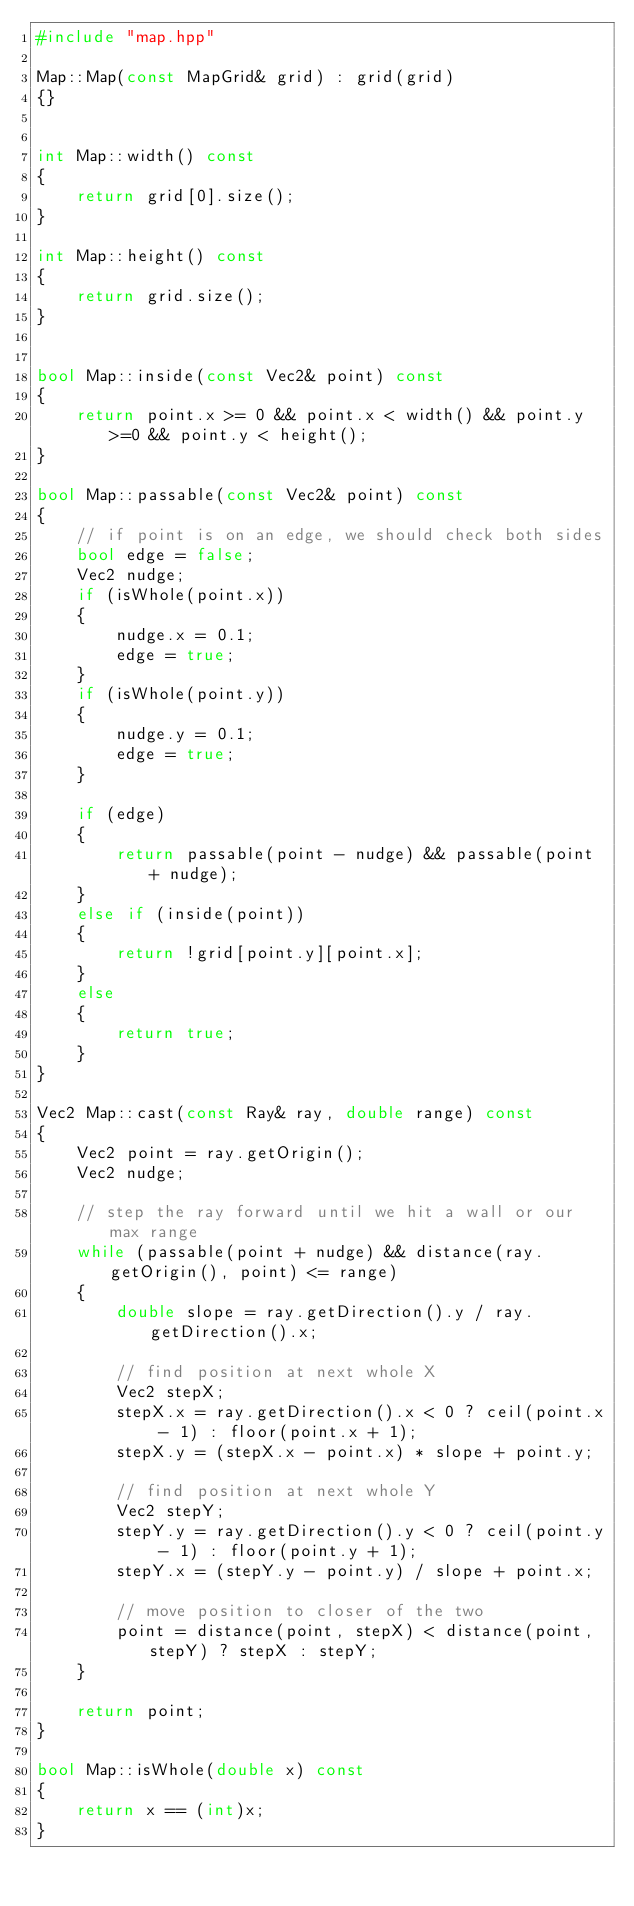Convert code to text. <code><loc_0><loc_0><loc_500><loc_500><_C++_>#include "map.hpp"

Map::Map(const MapGrid& grid) : grid(grid)
{}


int Map::width() const
{
    return grid[0].size();
}

int Map::height() const
{
    return grid.size();
}


bool Map::inside(const Vec2& point) const
{
    return point.x >= 0 && point.x < width() && point.y >=0 && point.y < height();
}

bool Map::passable(const Vec2& point) const
{
    // if point is on an edge, we should check both sides
    bool edge = false;
    Vec2 nudge;
    if (isWhole(point.x))
    {
        nudge.x = 0.1;
        edge = true;
    }
    if (isWhole(point.y))
    {
        nudge.y = 0.1;
        edge = true;
    }
    
    if (edge)
    {
        return passable(point - nudge) && passable(point + nudge);
    }
    else if (inside(point))
    {
        return !grid[point.y][point.x];
    }
    else
    {
        return true;
    }
}

Vec2 Map::cast(const Ray& ray, double range) const
{
    Vec2 point = ray.getOrigin();
    Vec2 nudge;
    
    // step the ray forward until we hit a wall or our max range
    while (passable(point + nudge) && distance(ray.getOrigin(), point) <= range)
    {
        double slope = ray.getDirection().y / ray.getDirection().x;
        
        // find position at next whole X
        Vec2 stepX;
        stepX.x = ray.getDirection().x < 0 ? ceil(point.x - 1) : floor(point.x + 1);
        stepX.y = (stepX.x - point.x) * slope + point.y;
        
        // find position at next whole Y
        Vec2 stepY;
        stepY.y = ray.getDirection().y < 0 ? ceil(point.y - 1) : floor(point.y + 1);
        stepY.x = (stepY.y - point.y) / slope + point.x;
        
        // move position to closer of the two
        point = distance(point, stepX) < distance(point, stepY) ? stepX : stepY;
    }
    
    return point;
}

bool Map::isWhole(double x) const
{
    return x == (int)x;
}
</code> 